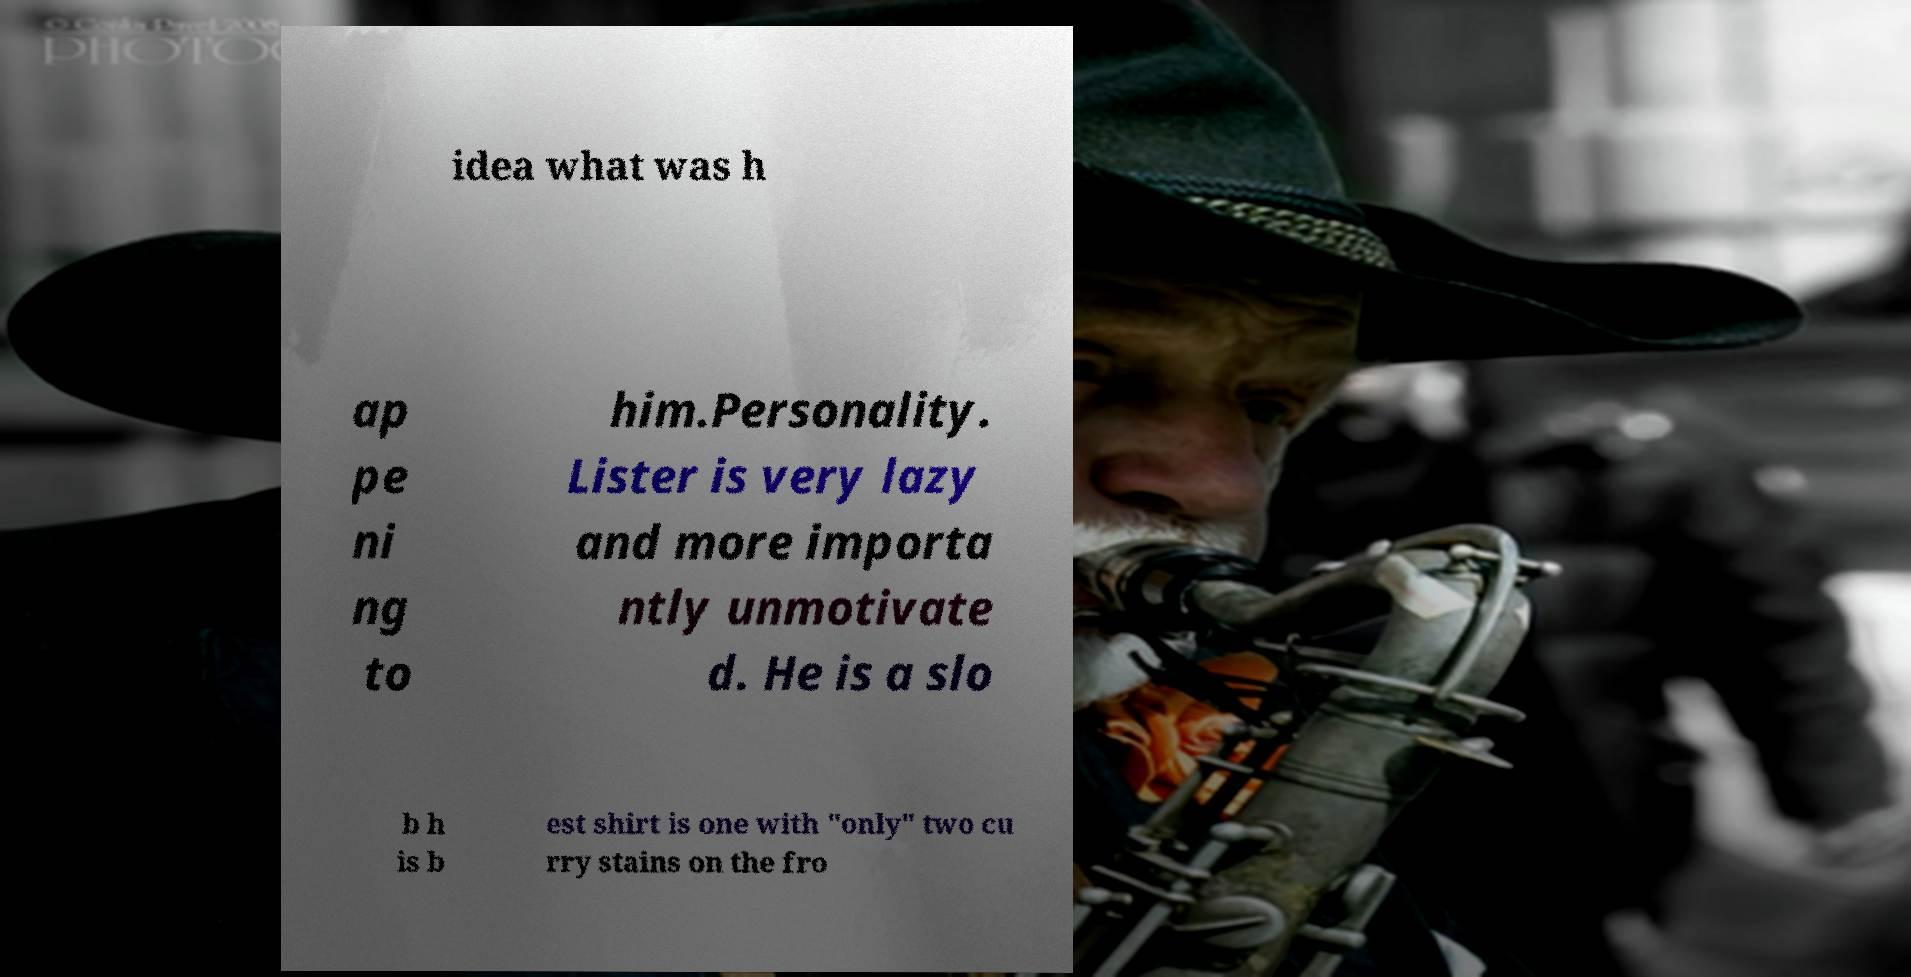For documentation purposes, I need the text within this image transcribed. Could you provide that? idea what was h ap pe ni ng to him.Personality. Lister is very lazy and more importa ntly unmotivate d. He is a slo b h is b est shirt is one with "only" two cu rry stains on the fro 